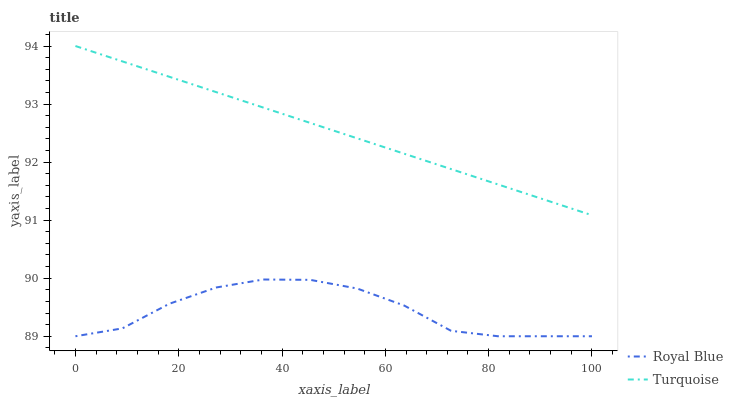Does Royal Blue have the minimum area under the curve?
Answer yes or no. Yes. Does Turquoise have the maximum area under the curve?
Answer yes or no. Yes. Does Turquoise have the minimum area under the curve?
Answer yes or no. No. Is Turquoise the smoothest?
Answer yes or no. Yes. Is Royal Blue the roughest?
Answer yes or no. Yes. Is Turquoise the roughest?
Answer yes or no. No. Does Royal Blue have the lowest value?
Answer yes or no. Yes. Does Turquoise have the lowest value?
Answer yes or no. No. Does Turquoise have the highest value?
Answer yes or no. Yes. Is Royal Blue less than Turquoise?
Answer yes or no. Yes. Is Turquoise greater than Royal Blue?
Answer yes or no. Yes. Does Royal Blue intersect Turquoise?
Answer yes or no. No. 